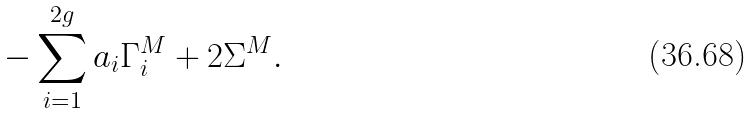Convert formula to latex. <formula><loc_0><loc_0><loc_500><loc_500>- \sum _ { i = 1 } ^ { 2 g } a _ { i } \Gamma _ { i } ^ { M } + 2 \Sigma ^ { M } .</formula> 